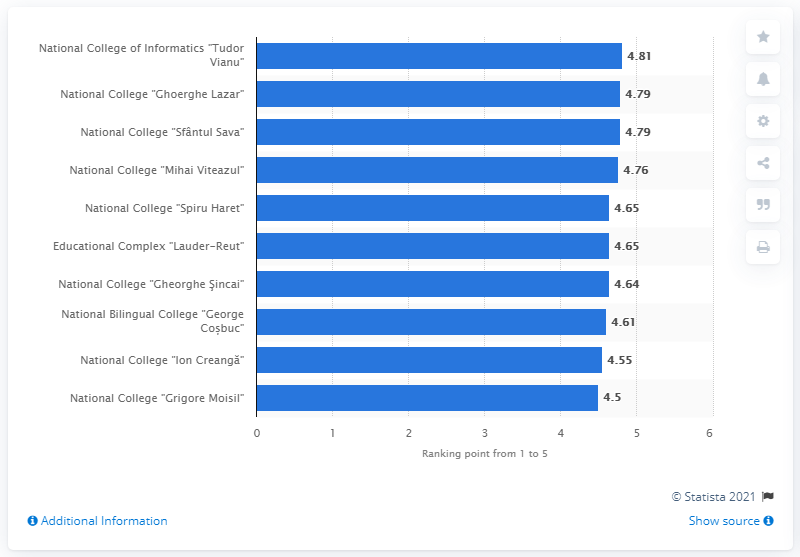List a handful of essential elements in this visual. The National College "Grigore Moisil" ranked 10th in 2019 according to the School Inspectorate of the Bucharest Municipality. 